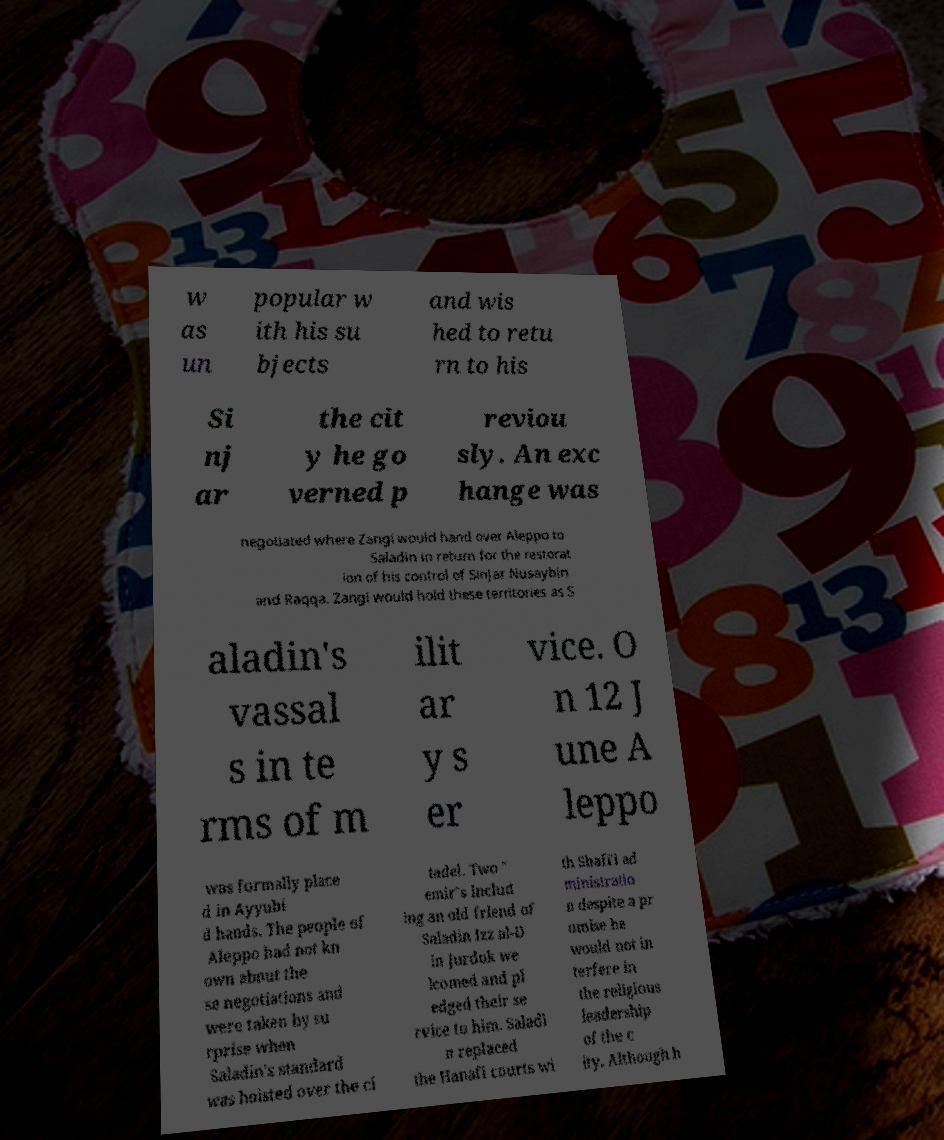Could you extract and type out the text from this image? w as un popular w ith his su bjects and wis hed to retu rn to his Si nj ar the cit y he go verned p reviou sly. An exc hange was negotiated where Zangi would hand over Aleppo to Saladin in return for the restorat ion of his control of Sinjar Nusaybin and Raqqa. Zangi would hold these territories as S aladin's vassal s in te rms of m ilit ar y s er vice. O n 12 J une A leppo was formally place d in Ayyubi d hands. The people of Aleppo had not kn own about the se negotiations and were taken by su rprise when Saladin's standard was hoisted over the ci tadel. Two " emir"s includ ing an old friend of Saladin Izz al-D in Jurduk we lcomed and pl edged their se rvice to him. Saladi n replaced the Hanafi courts wi th Shafi'i ad ministratio n despite a pr omise he would not in terfere in the religious leadership of the c ity. Although h 